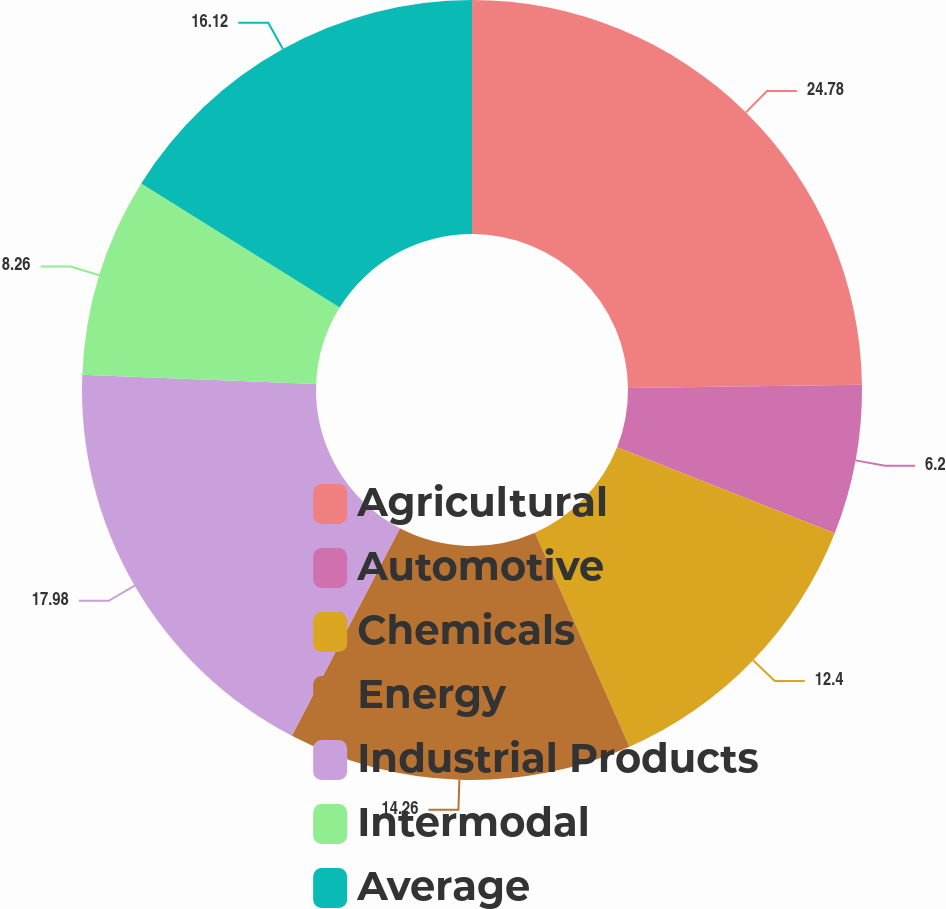<chart> <loc_0><loc_0><loc_500><loc_500><pie_chart><fcel>Agricultural<fcel>Automotive<fcel>Chemicals<fcel>Energy<fcel>Industrial Products<fcel>Intermodal<fcel>Average<nl><fcel>24.79%<fcel>6.2%<fcel>12.4%<fcel>14.26%<fcel>17.98%<fcel>8.26%<fcel>16.12%<nl></chart> 